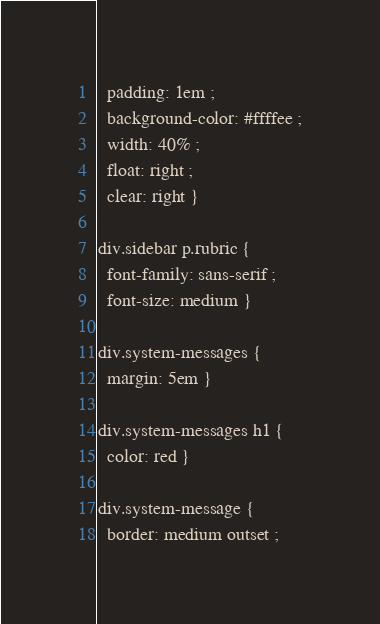Convert code to text. <code><loc_0><loc_0><loc_500><loc_500><_HTML_>  padding: 1em ;
  background-color: #ffffee ;
  width: 40% ;
  float: right ;
  clear: right }

div.sidebar p.rubric {
  font-family: sans-serif ;
  font-size: medium }

div.system-messages {
  margin: 5em }

div.system-messages h1 {
  color: red }

div.system-message {
  border: medium outset ;</code> 